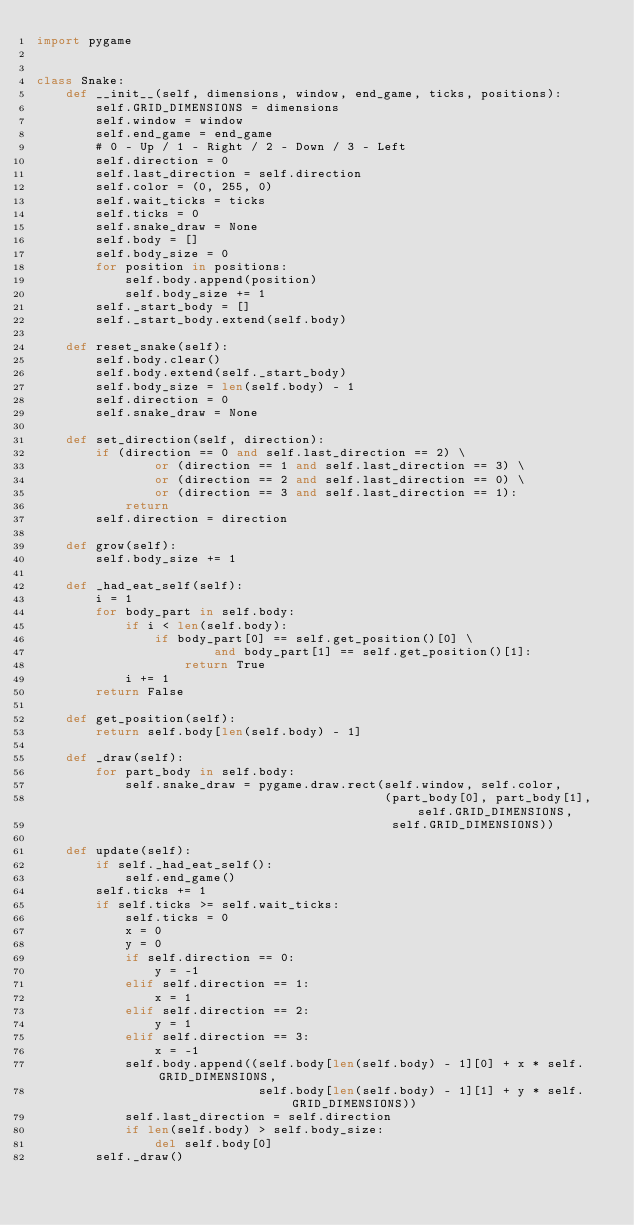Convert code to text. <code><loc_0><loc_0><loc_500><loc_500><_Python_>import pygame


class Snake:
    def __init__(self, dimensions, window, end_game, ticks, positions):
        self.GRID_DIMENSIONS = dimensions
        self.window = window
        self.end_game = end_game
        # 0 - Up / 1 - Right / 2 - Down / 3 - Left
        self.direction = 0
        self.last_direction = self.direction
        self.color = (0, 255, 0)
        self.wait_ticks = ticks
        self.ticks = 0
        self.snake_draw = None
        self.body = []
        self.body_size = 0
        for position in positions:
            self.body.append(position)
            self.body_size += 1
        self._start_body = []
        self._start_body.extend(self.body)

    def reset_snake(self):
        self.body.clear()
        self.body.extend(self._start_body)
        self.body_size = len(self.body) - 1
        self.direction = 0
        self.snake_draw = None

    def set_direction(self, direction):
        if (direction == 0 and self.last_direction == 2) \
                or (direction == 1 and self.last_direction == 3) \
                or (direction == 2 and self.last_direction == 0) \
                or (direction == 3 and self.last_direction == 1):
            return
        self.direction = direction

    def grow(self):
        self.body_size += 1

    def _had_eat_self(self):
        i = 1
        for body_part in self.body:
            if i < len(self.body):
                if body_part[0] == self.get_position()[0] \
                        and body_part[1] == self.get_position()[1]:
                    return True
            i += 1
        return False

    def get_position(self):
        return self.body[len(self.body) - 1]

    def _draw(self):
        for part_body in self.body:
            self.snake_draw = pygame.draw.rect(self.window, self.color,
                                               (part_body[0], part_body[1], self.GRID_DIMENSIONS,
                                                self.GRID_DIMENSIONS))

    def update(self):
        if self._had_eat_self():
            self.end_game()
        self.ticks += 1
        if self.ticks >= self.wait_ticks:
            self.ticks = 0
            x = 0
            y = 0
            if self.direction == 0:
                y = -1
            elif self.direction == 1:
                x = 1
            elif self.direction == 2:
                y = 1
            elif self.direction == 3:
                x = -1
            self.body.append((self.body[len(self.body) - 1][0] + x * self.GRID_DIMENSIONS,
                              self.body[len(self.body) - 1][1] + y * self.GRID_DIMENSIONS))
            self.last_direction = self.direction
            if len(self.body) > self.body_size:
                del self.body[0]
        self._draw()
</code> 